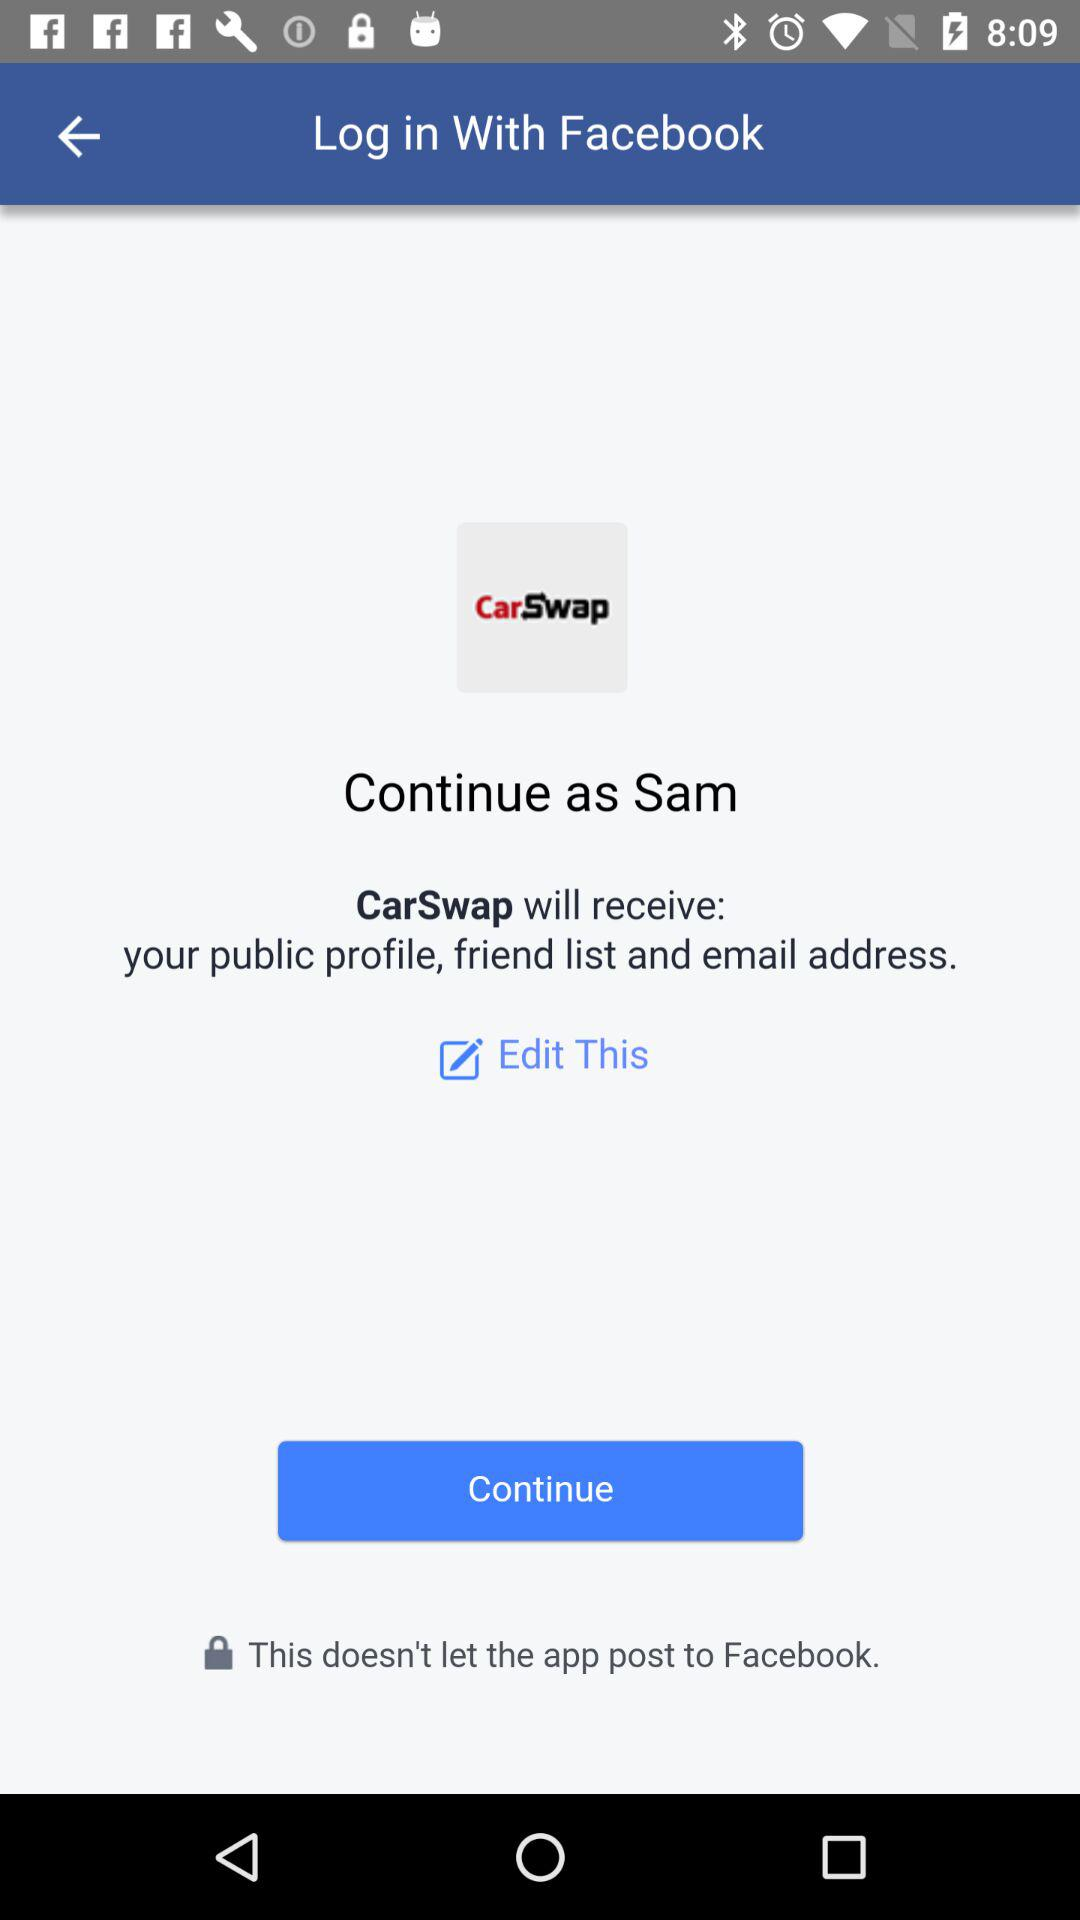What application is asking for permission? The application asking for permission is "CarSwap". 